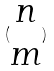Convert formula to latex. <formula><loc_0><loc_0><loc_500><loc_500>( \begin{matrix} n \\ m \end{matrix} )</formula> 